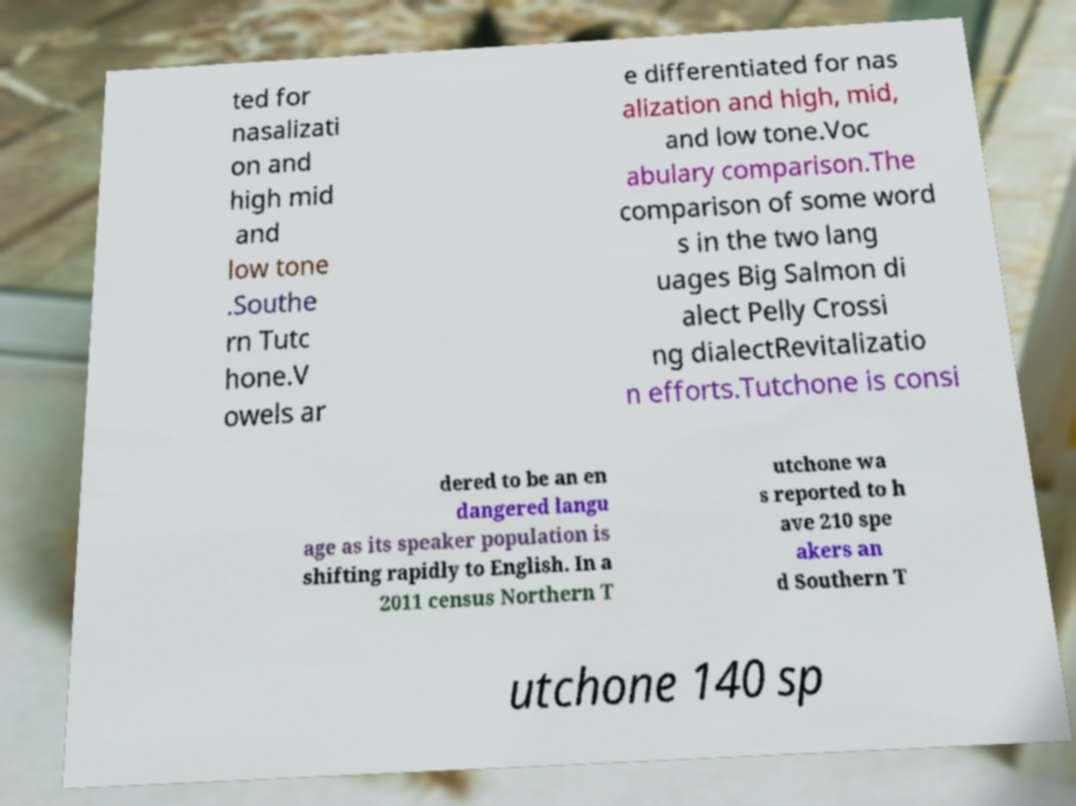There's text embedded in this image that I need extracted. Can you transcribe it verbatim? ted for nasalizati on and high mid and low tone .Southe rn Tutc hone.V owels ar e differentiated for nas alization and high, mid, and low tone.Voc abulary comparison.The comparison of some word s in the two lang uages Big Salmon di alect Pelly Crossi ng dialectRevitalizatio n efforts.Tutchone is consi dered to be an en dangered langu age as its speaker population is shifting rapidly to English. In a 2011 census Northern T utchone wa s reported to h ave 210 spe akers an d Southern T utchone 140 sp 